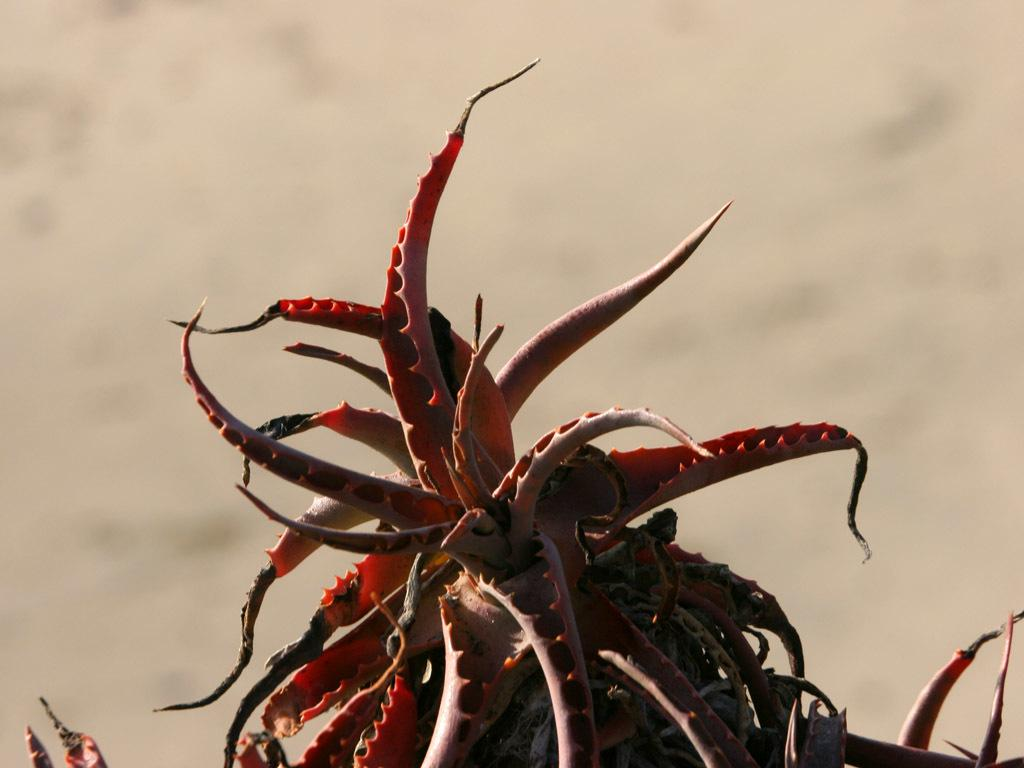What is present in the image? There is a plant in the image. Can you describe the plant's appearance? The plant is of red color. Is there a cap on the plant in the image? No, there is no cap present on the plant in the image. 